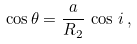<formula> <loc_0><loc_0><loc_500><loc_500>\cos \theta = \frac { a } { R _ { 2 } } \, \cos \, i \, ,</formula> 